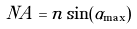Convert formula to latex. <formula><loc_0><loc_0><loc_500><loc_500>N A = n \sin ( \alpha _ { \max } )</formula> 